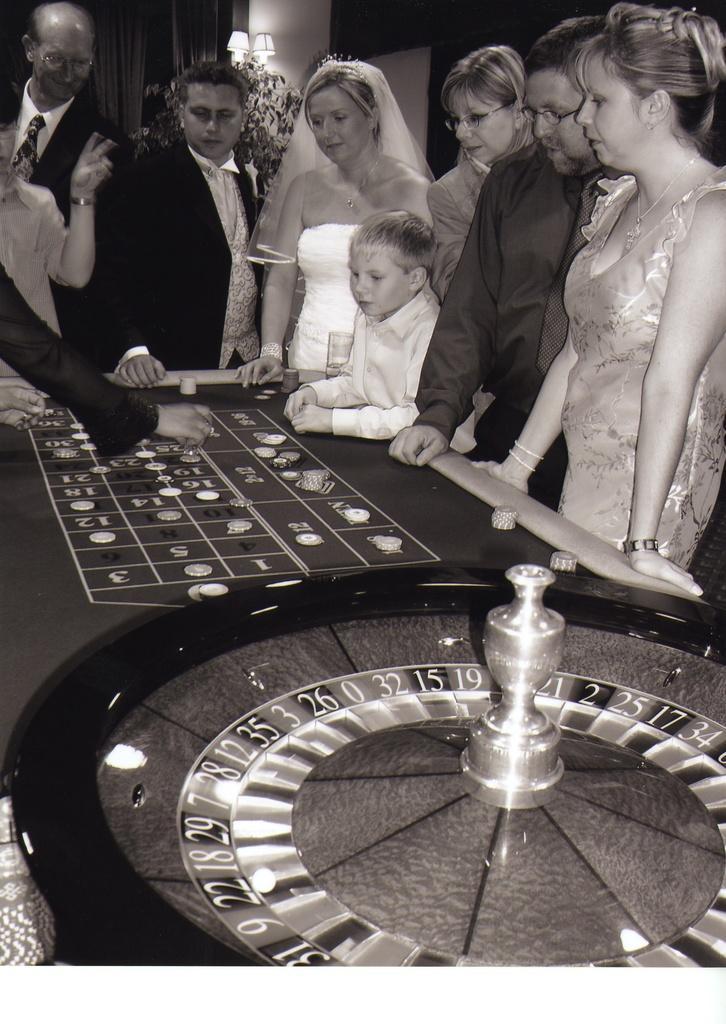Can you describe this image briefly? This persons are standing in-front of this table. On this table there are coins, wheel and numbers. Far there are lantern lamps and curtains. This is a black and white picture. 